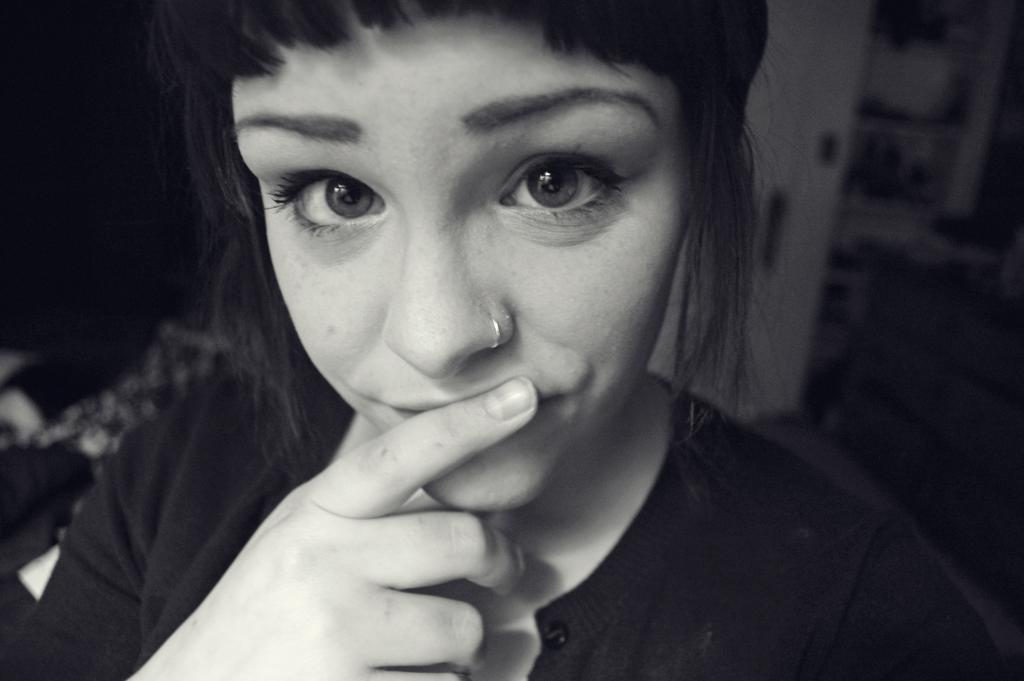What is the main subject of the image? There is a woman in the image. What can be said about the color scheme of the image? The image is black and white in color. How many cows are visible in the image? There are no cows present in the image. What type of underwear is the woman wearing in the image? The image is black and white, and it is not possible to determine the type of underwear the woman might be wearing. 